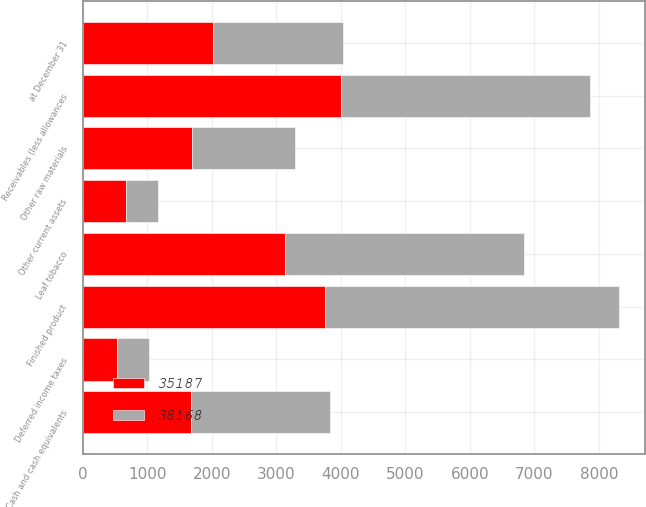Convert chart. <chart><loc_0><loc_0><loc_500><loc_500><stacked_bar_chart><ecel><fcel>at December 31<fcel>Cash and cash equivalents<fcel>Receivables (less allowances<fcel>Leaf tobacco<fcel>Other raw materials<fcel>Finished product<fcel>Deferred income taxes<fcel>Other current assets<nl><fcel>35187<fcel>2014<fcel>1682<fcel>4004<fcel>3135<fcel>1696<fcel>3761<fcel>533<fcel>673<nl><fcel>38168<fcel>2013<fcel>2154<fcel>3853<fcel>3709<fcel>1596<fcel>4541<fcel>502<fcel>497<nl></chart> 